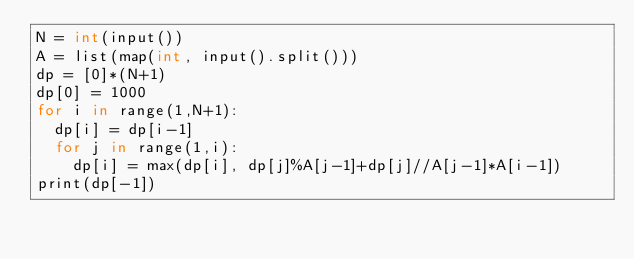<code> <loc_0><loc_0><loc_500><loc_500><_Cython_>N = int(input())
A = list(map(int, input().split()))
dp = [0]*(N+1)
dp[0] = 1000
for i in range(1,N+1):
  dp[i] = dp[i-1]
  for j in range(1,i):
    dp[i] = max(dp[i], dp[j]%A[j-1]+dp[j]//A[j-1]*A[i-1])
print(dp[-1])</code> 